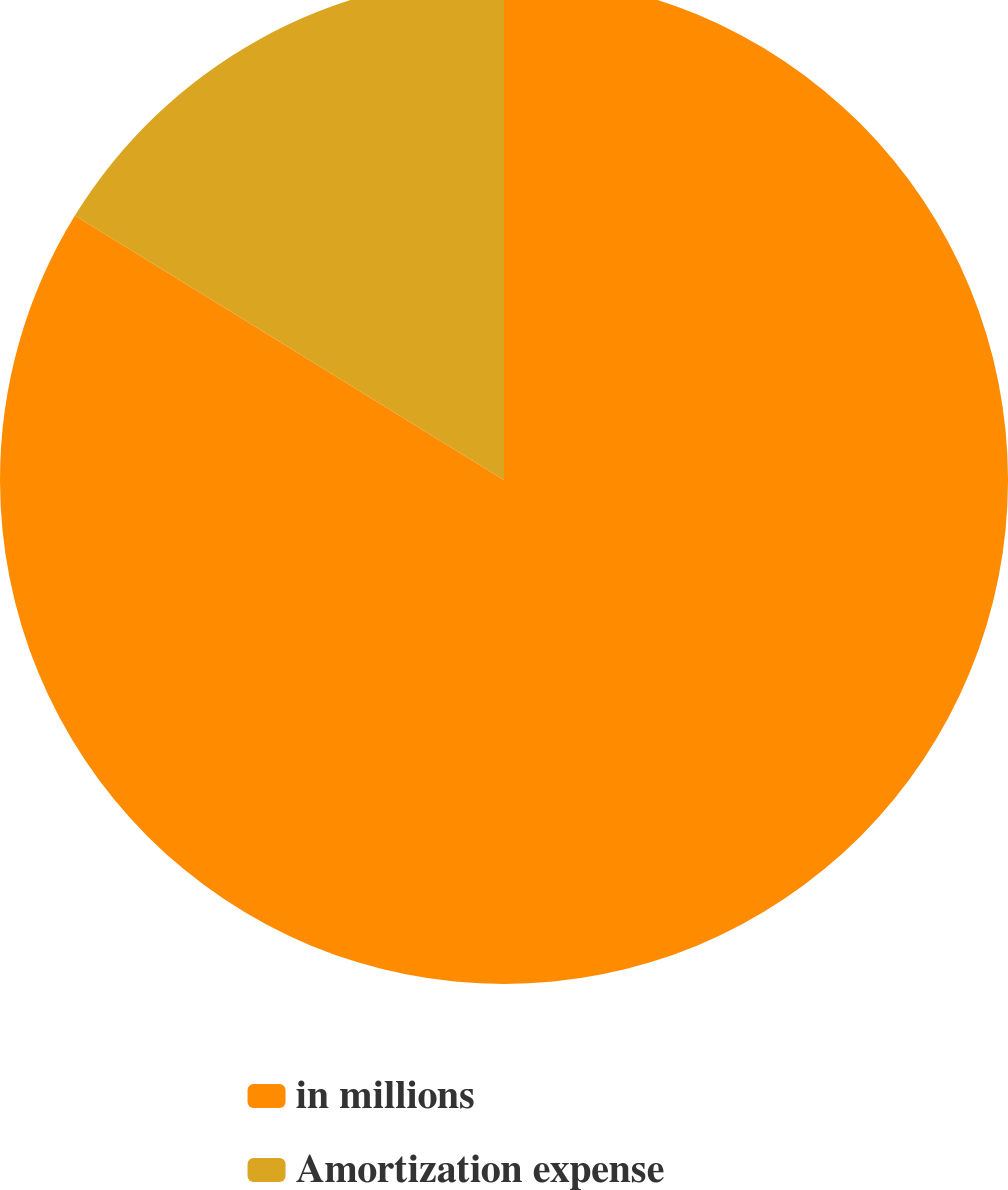Convert chart. <chart><loc_0><loc_0><loc_500><loc_500><pie_chart><fcel>in millions<fcel>Amortization expense<nl><fcel>83.79%<fcel>16.21%<nl></chart> 